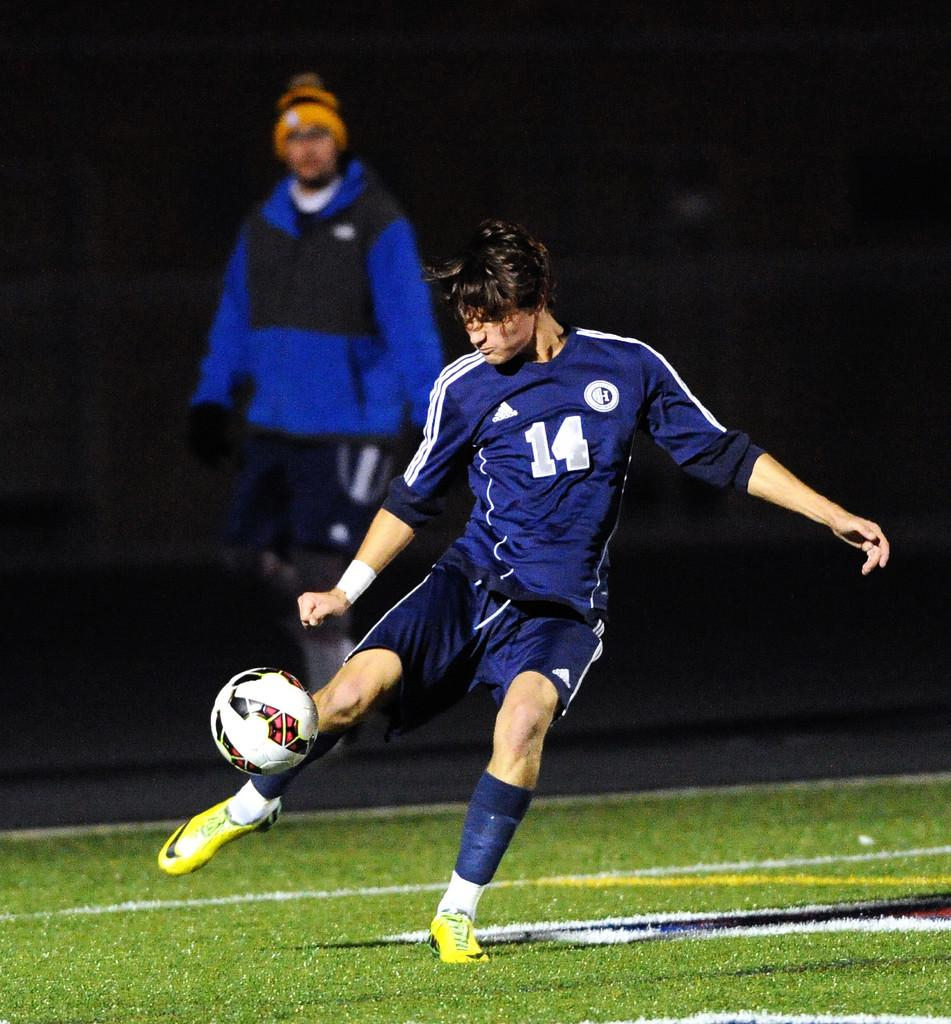Provide a one-sentence caption for the provided image. a football player in yellow boots kicking a ball with a number 14 on his shirt. 